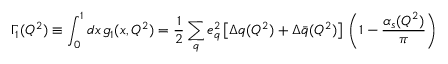<formula> <loc_0><loc_0><loc_500><loc_500>\Gamma _ { 1 } ( Q ^ { 2 } ) \equiv \int _ { 0 } ^ { 1 } d x \, g _ { 1 } ( x , Q ^ { 2 } ) = \frac { 1 } { 2 } \sum _ { q } e _ { q } ^ { 2 } \left [ \Delta q ( Q ^ { 2 } ) + \Delta \bar { q } ( Q ^ { 2 } ) \right ] \, \left ( 1 - \frac { \alpha _ { s } ( Q ^ { 2 } ) } { \pi } \right )</formula> 